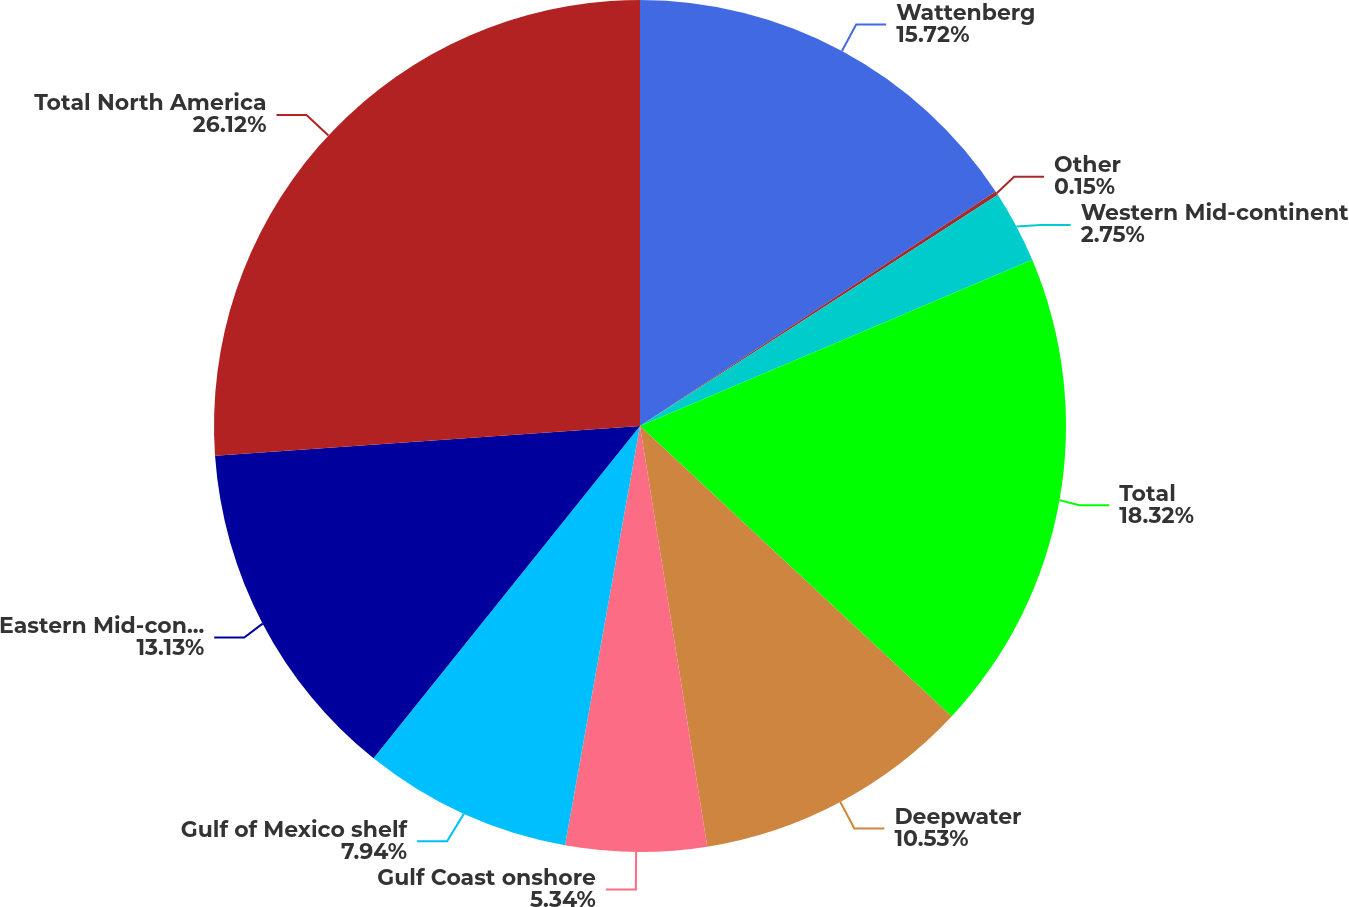Convert chart to OTSL. <chart><loc_0><loc_0><loc_500><loc_500><pie_chart><fcel>Wattenberg<fcel>Other<fcel>Western Mid-continent<fcel>Total<fcel>Deepwater<fcel>Gulf Coast onshore<fcel>Gulf of Mexico shelf<fcel>Eastern Mid-continent<fcel>Total North America<nl><fcel>15.72%<fcel>0.15%<fcel>2.75%<fcel>18.32%<fcel>10.53%<fcel>5.34%<fcel>7.94%<fcel>13.13%<fcel>26.11%<nl></chart> 